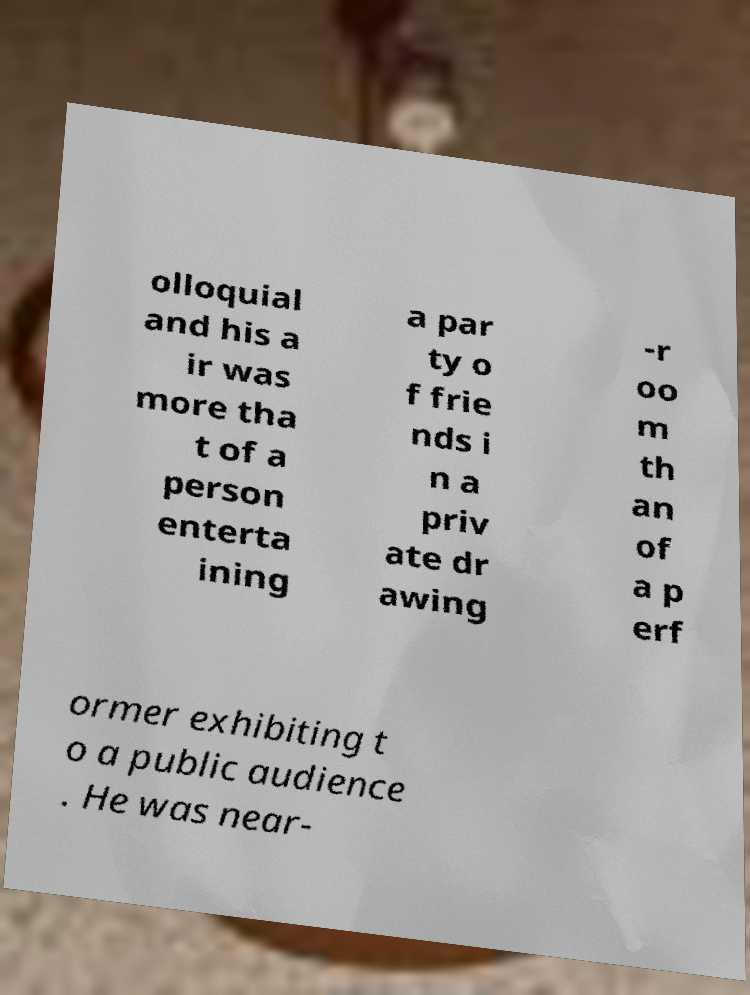There's text embedded in this image that I need extracted. Can you transcribe it verbatim? olloquial and his a ir was more tha t of a person enterta ining a par ty o f frie nds i n a priv ate dr awing -r oo m th an of a p erf ormer exhibiting t o a public audience . He was near- 